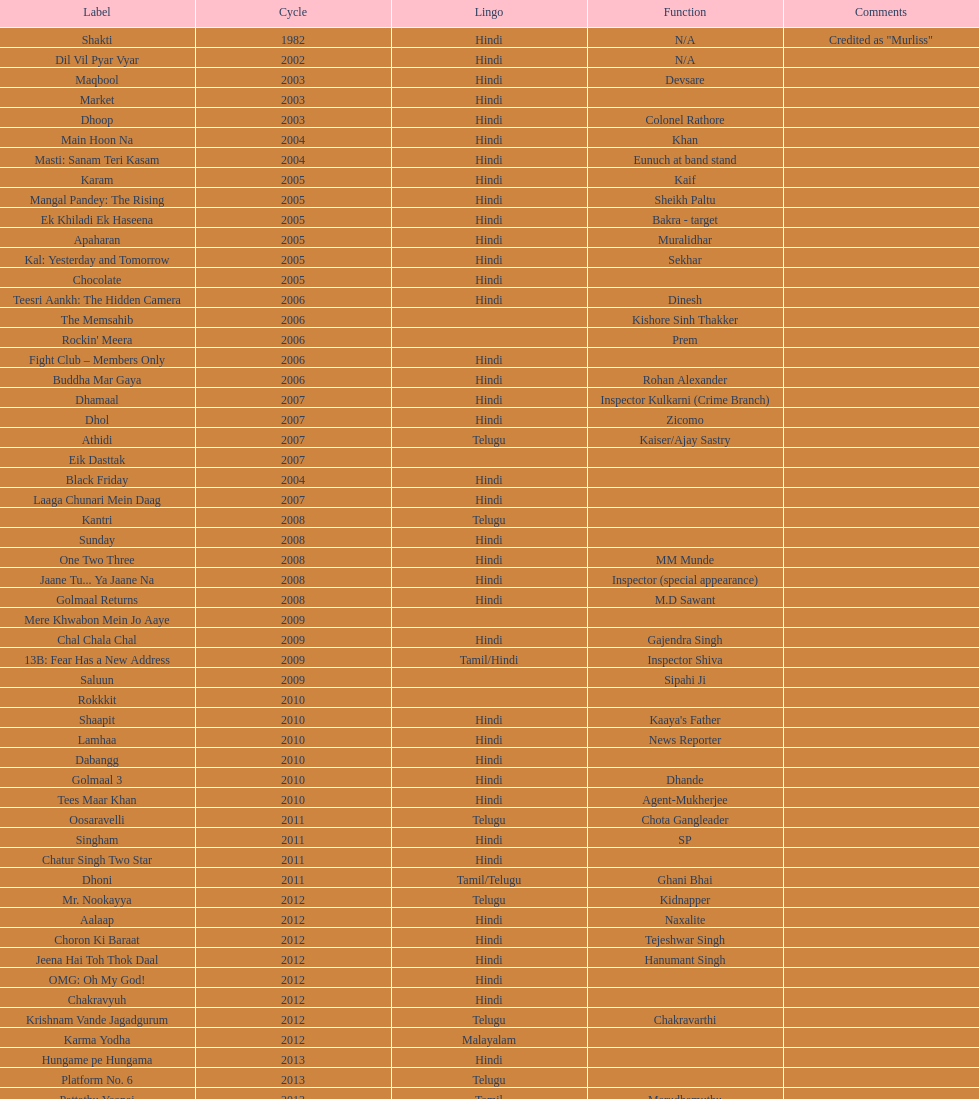What is the total years on the chart 13. 